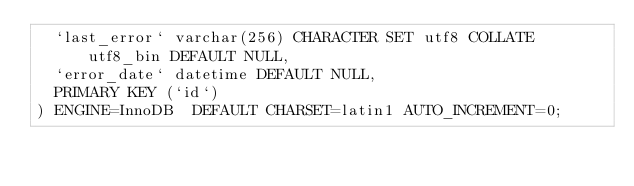<code> <loc_0><loc_0><loc_500><loc_500><_SQL_>  `last_error` varchar(256) CHARACTER SET utf8 COLLATE utf8_bin DEFAULT NULL,
  `error_date` datetime DEFAULT NULL,
  PRIMARY KEY (`id`)
) ENGINE=InnoDB  DEFAULT CHARSET=latin1 AUTO_INCREMENT=0;
</code> 